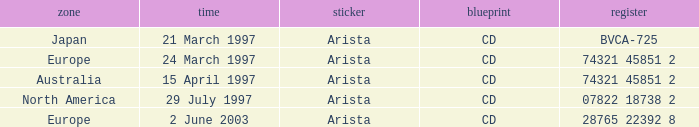For the european region, what is the date linked to the catalog entry 28765 22392 8? 2 June 2003. 